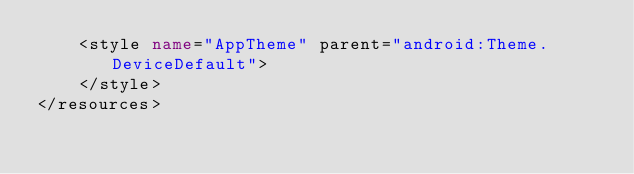Convert code to text. <code><loc_0><loc_0><loc_500><loc_500><_XML_>    <style name="AppTheme" parent="android:Theme.DeviceDefault">
    </style>
</resources>
</code> 